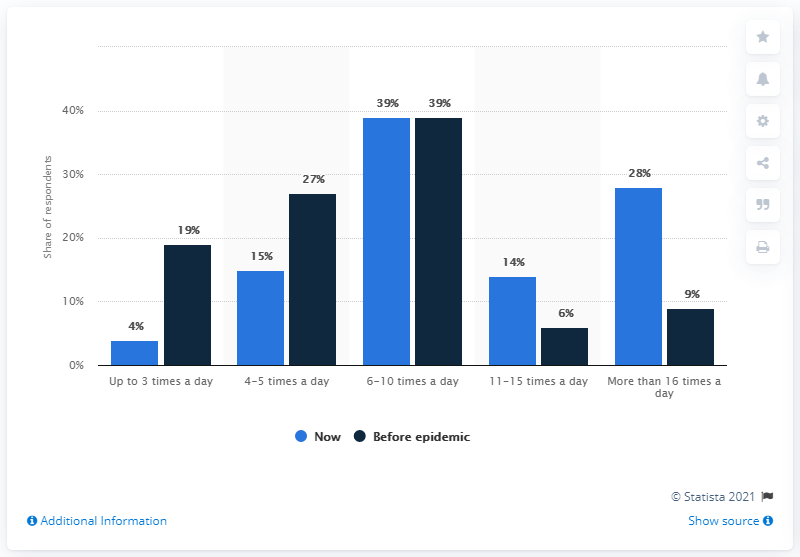Give some essential details in this illustration. The highest bar and the lowest bar in the chart represent the 35th percentile and the 1st percentile, respectively. The lowest bar value in the chart is 4. 